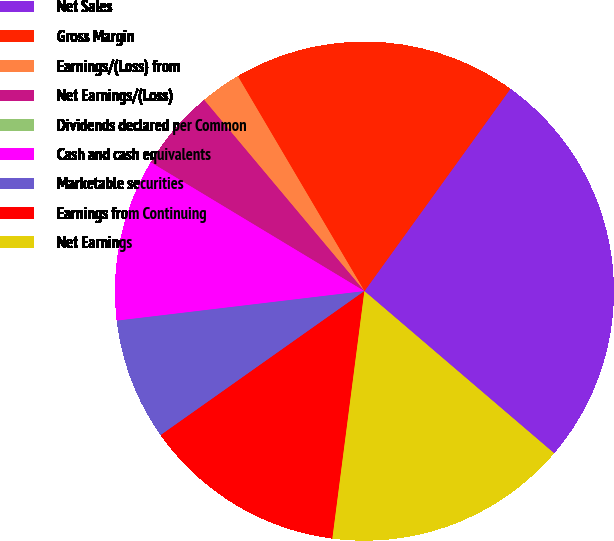<chart> <loc_0><loc_0><loc_500><loc_500><pie_chart><fcel>Net Sales<fcel>Gross Margin<fcel>Earnings/(Loss) from<fcel>Net Earnings/(Loss)<fcel>Dividends declared per Common<fcel>Cash and cash equivalents<fcel>Marketable securities<fcel>Earnings from Continuing<fcel>Net Earnings<nl><fcel>26.31%<fcel>18.42%<fcel>2.63%<fcel>5.26%<fcel>0.0%<fcel>10.53%<fcel>7.9%<fcel>13.16%<fcel>15.79%<nl></chart> 